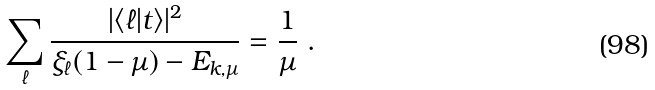Convert formula to latex. <formula><loc_0><loc_0><loc_500><loc_500>\sum _ { \ell } \frac { | \langle \ell | t \rangle | ^ { 2 } } { \xi _ { \ell } ( 1 - \mu ) - E _ { k , \mu } } = \frac { 1 } { \mu } \ .</formula> 